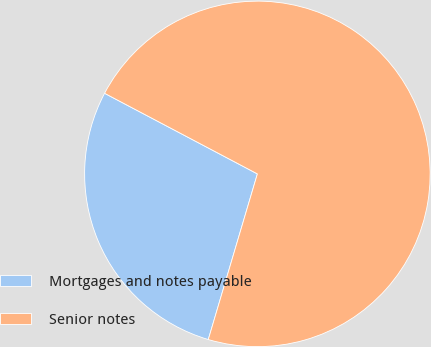<chart> <loc_0><loc_0><loc_500><loc_500><pie_chart><fcel>Mortgages and notes payable<fcel>Senior notes<nl><fcel>28.14%<fcel>71.86%<nl></chart> 